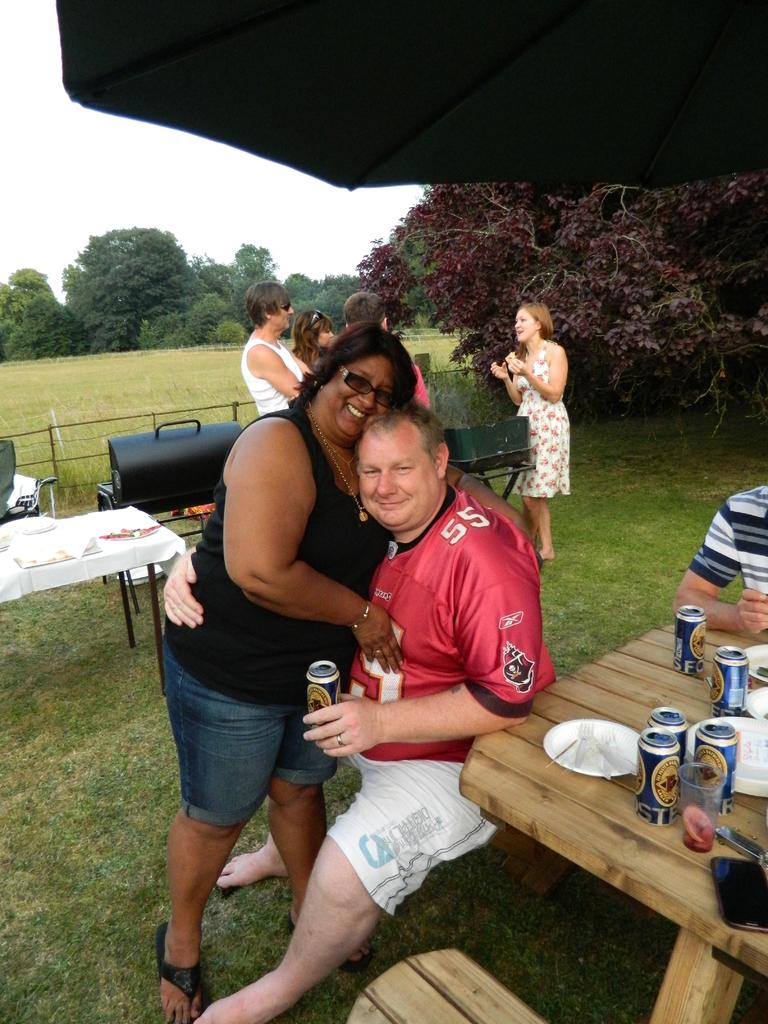<image>
Write a terse but informative summary of the picture. A woman hugging a man with the number 55 on his shirt. 